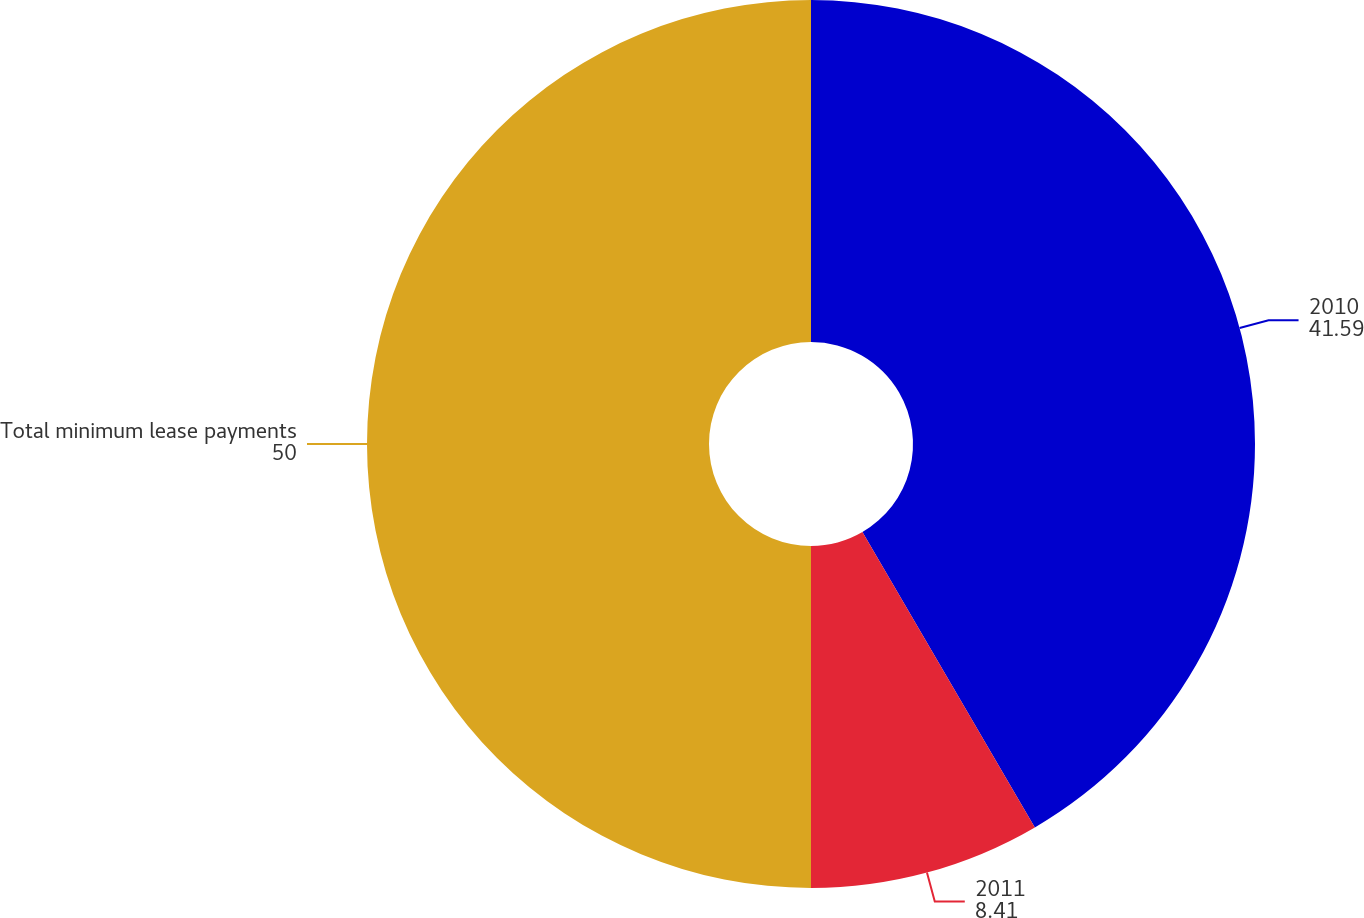Convert chart. <chart><loc_0><loc_0><loc_500><loc_500><pie_chart><fcel>2010<fcel>2011<fcel>Total minimum lease payments<nl><fcel>41.59%<fcel>8.41%<fcel>50.0%<nl></chart> 